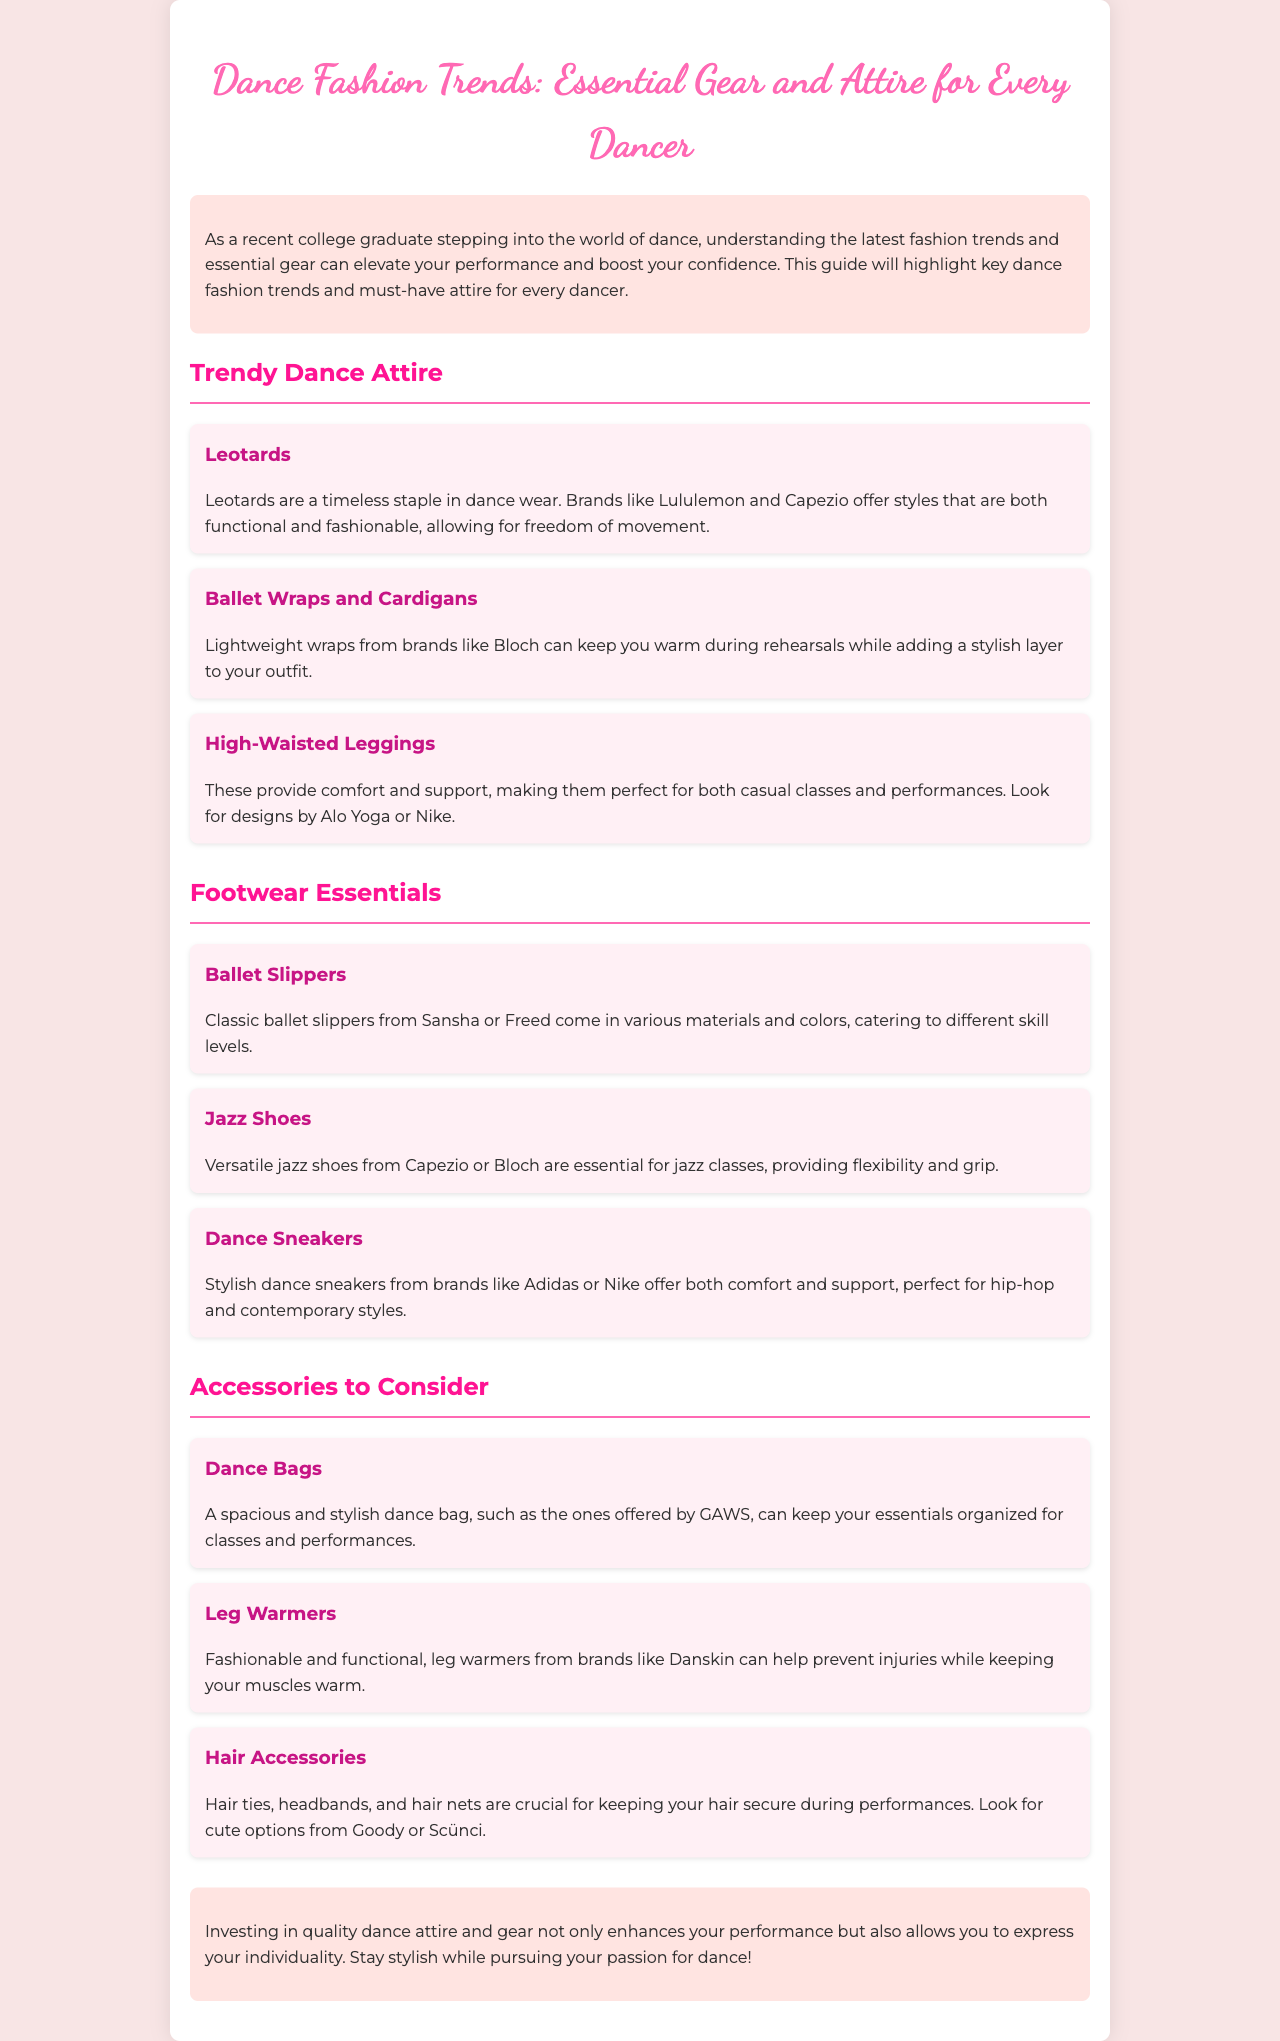What are the trendy dance attires mentioned? The document lists leotards, ballet wraps and cardigans, and high-waisted leggings as trendy dance attires.
Answer: leotards, ballet wraps and cardigans, high-waisted leggings Which brands offer ballet slippers? The document mentions Sansha and Freed as brands that provide ballet slippers.
Answer: Sansha, Freed What type of dance shoe is essential for jazz classes? The document states that jazz shoes are essential for jazz classes.
Answer: jazz shoes What do leg warmers help prevent? According to the document, leg warmers help prevent injuries while keeping muscles warm.
Answer: injuries What should you look for in hair accessories? The document suggests looking for options that keep your hair secure during performances.
Answer: secure options What is the purpose of a dance bag? The dance bag is meant to keep essentials organized for classes and performances.
Answer: organize essentials How many sections are in the brochure? The brochure has three main sections: Trendy Dance Attire, Footwear Essentials, and Accessories to Consider.
Answer: three What is one benefit of investing in quality dance attire? The document states that investing in quality dance attire enhances your performance.
Answer: enhances performance 